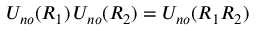Convert formula to latex. <formula><loc_0><loc_0><loc_500><loc_500>U _ { n o } ( R _ { 1 } ) \, U _ { n o } ( R _ { 2 } ) = U _ { n o } ( R _ { 1 } R _ { 2 } )</formula> 